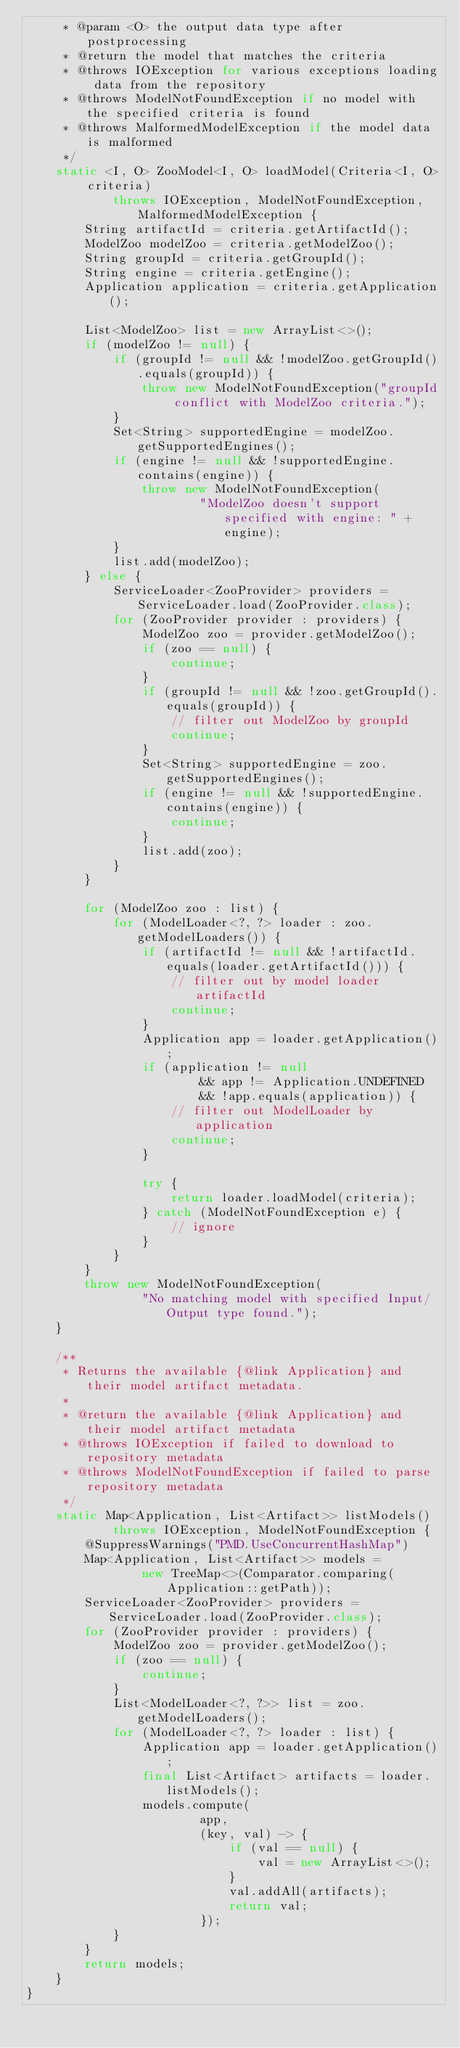<code> <loc_0><loc_0><loc_500><loc_500><_Java_>     * @param <O> the output data type after postprocessing
     * @return the model that matches the criteria
     * @throws IOException for various exceptions loading data from the repository
     * @throws ModelNotFoundException if no model with the specified criteria is found
     * @throws MalformedModelException if the model data is malformed
     */
    static <I, O> ZooModel<I, O> loadModel(Criteria<I, O> criteria)
            throws IOException, ModelNotFoundException, MalformedModelException {
        String artifactId = criteria.getArtifactId();
        ModelZoo modelZoo = criteria.getModelZoo();
        String groupId = criteria.getGroupId();
        String engine = criteria.getEngine();
        Application application = criteria.getApplication();

        List<ModelZoo> list = new ArrayList<>();
        if (modelZoo != null) {
            if (groupId != null && !modelZoo.getGroupId().equals(groupId)) {
                throw new ModelNotFoundException("groupId conflict with ModelZoo criteria.");
            }
            Set<String> supportedEngine = modelZoo.getSupportedEngines();
            if (engine != null && !supportedEngine.contains(engine)) {
                throw new ModelNotFoundException(
                        "ModelZoo doesn't support specified with engine: " + engine);
            }
            list.add(modelZoo);
        } else {
            ServiceLoader<ZooProvider> providers = ServiceLoader.load(ZooProvider.class);
            for (ZooProvider provider : providers) {
                ModelZoo zoo = provider.getModelZoo();
                if (zoo == null) {
                    continue;
                }
                if (groupId != null && !zoo.getGroupId().equals(groupId)) {
                    // filter out ModelZoo by groupId
                    continue;
                }
                Set<String> supportedEngine = zoo.getSupportedEngines();
                if (engine != null && !supportedEngine.contains(engine)) {
                    continue;
                }
                list.add(zoo);
            }
        }

        for (ModelZoo zoo : list) {
            for (ModelLoader<?, ?> loader : zoo.getModelLoaders()) {
                if (artifactId != null && !artifactId.equals(loader.getArtifactId())) {
                    // filter out by model loader artifactId
                    continue;
                }
                Application app = loader.getApplication();
                if (application != null
                        && app != Application.UNDEFINED
                        && !app.equals(application)) {
                    // filter out ModelLoader by application
                    continue;
                }

                try {
                    return loader.loadModel(criteria);
                } catch (ModelNotFoundException e) {
                    // ignore
                }
            }
        }
        throw new ModelNotFoundException(
                "No matching model with specified Input/Output type found.");
    }

    /**
     * Returns the available {@link Application} and their model artifact metadata.
     *
     * @return the available {@link Application} and their model artifact metadata
     * @throws IOException if failed to download to repository metadata
     * @throws ModelNotFoundException if failed to parse repository metadata
     */
    static Map<Application, List<Artifact>> listModels()
            throws IOException, ModelNotFoundException {
        @SuppressWarnings("PMD.UseConcurrentHashMap")
        Map<Application, List<Artifact>> models =
                new TreeMap<>(Comparator.comparing(Application::getPath));
        ServiceLoader<ZooProvider> providers = ServiceLoader.load(ZooProvider.class);
        for (ZooProvider provider : providers) {
            ModelZoo zoo = provider.getModelZoo();
            if (zoo == null) {
                continue;
            }
            List<ModelLoader<?, ?>> list = zoo.getModelLoaders();
            for (ModelLoader<?, ?> loader : list) {
                Application app = loader.getApplication();
                final List<Artifact> artifacts = loader.listModels();
                models.compute(
                        app,
                        (key, val) -> {
                            if (val == null) {
                                val = new ArrayList<>();
                            }
                            val.addAll(artifacts);
                            return val;
                        });
            }
        }
        return models;
    }
}
</code> 